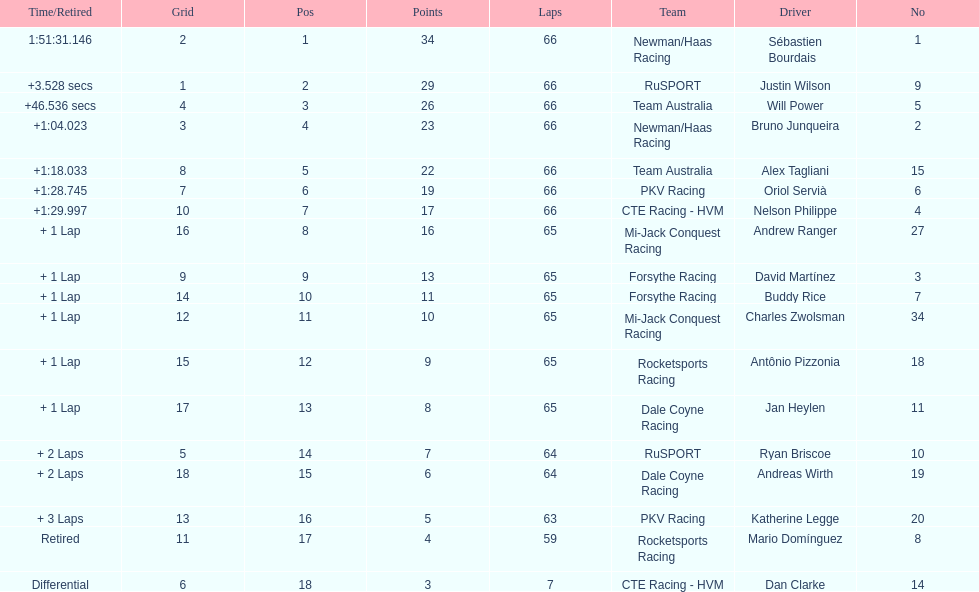Rice finished 10th. who finished next? Charles Zwolsman. 